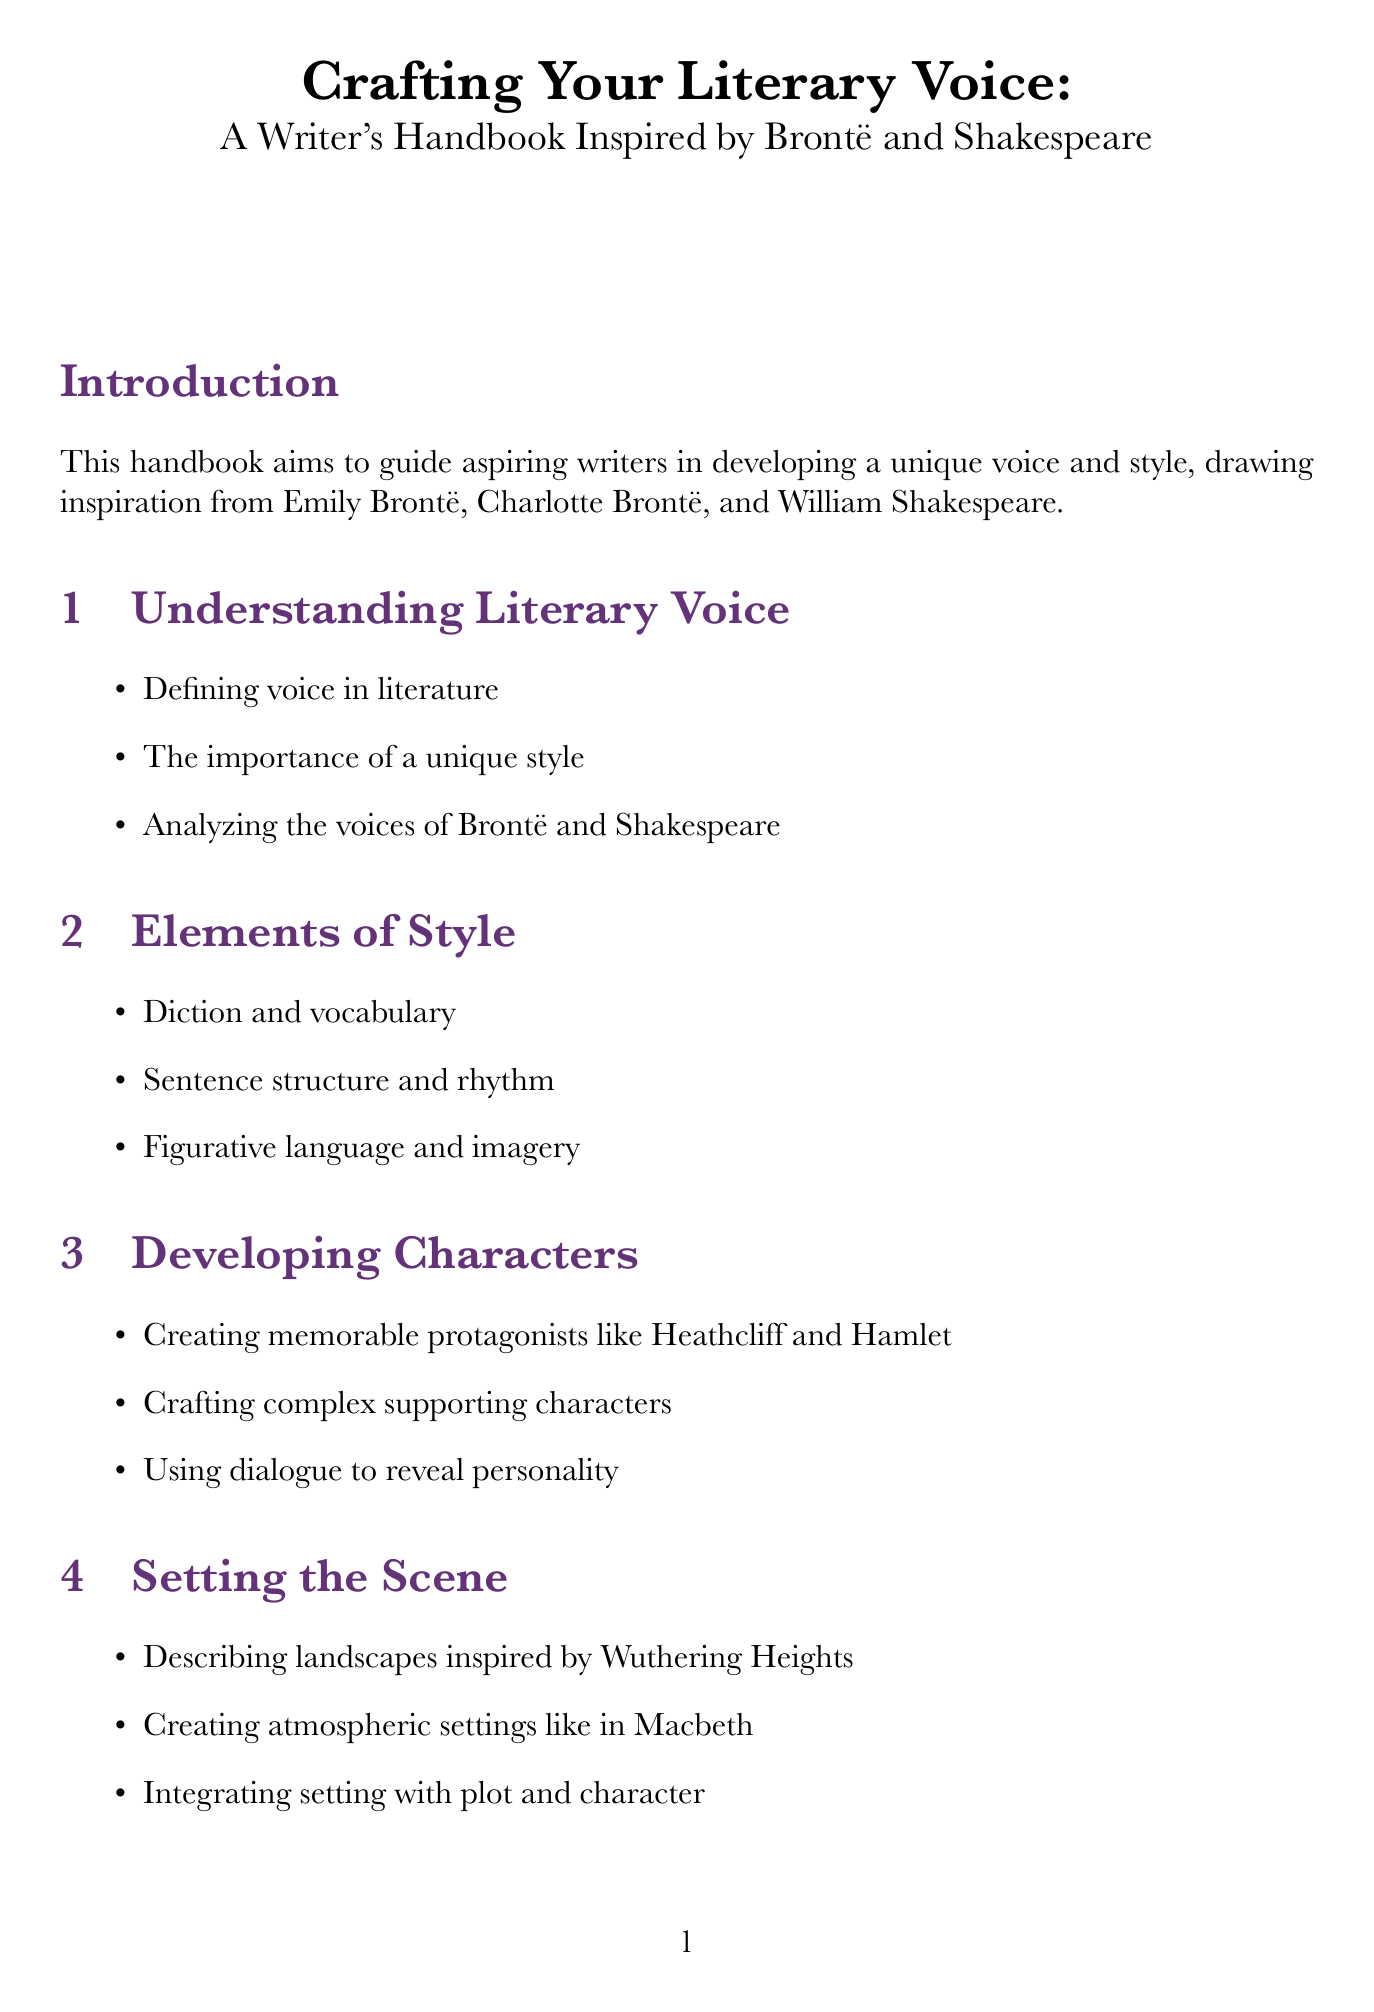What is the title of the handbook? The title is stated at the beginning of the document, introducing the main focus of the material.
Answer: Crafting Your Literary Voice: A Writer's Handbook Inspired by Brontë and Shakespeare Who is one of the authors mentioned as an inspiration? The introduction lists several influential authors who serve as inspirations for developing a unique voice and style.
Answer: Emily Brontë What is one component of style discussed in the document? The chapters outline specific elements crucial to writing style, and one of these elements is mentioned in the second chapter.
Answer: Diction and vocabulary How long is the “Dialogue Practice” exercise? The description of each exercise includes a specified duration, which is provided in the exercises section.
Answer: 45 minutes Which character is suggested for inspiration in the "Character Sketch"? The exercise description indicates specific characters from literature that writers can use as inspiration for their character sketches.
Answer: Catherine Earnshaw How many resources are listed under "Essential Reading List"? The resources section includes a list of essential readings that aspiring writers should explore, including the count of items listed.
Answer: 5 What type of literary device is highlighted in the "Mastering Literary Devices" chapter? Each section delves into various literary devices, and one device is specifically noted in the chapter.
Answer: Soliloquies Which exercise involves rewriting a classic scene? The exercise descriptions enumerate various writing practices, including one focused on modern adaptations of classic literature.
Answer: Adapting Classic Scenes What is one of the additional topics covered in the document? The additional topics section includes various themes related to writing, discussing contemporary relevance and historical context.
Answer: The influence of historical context on writing style 